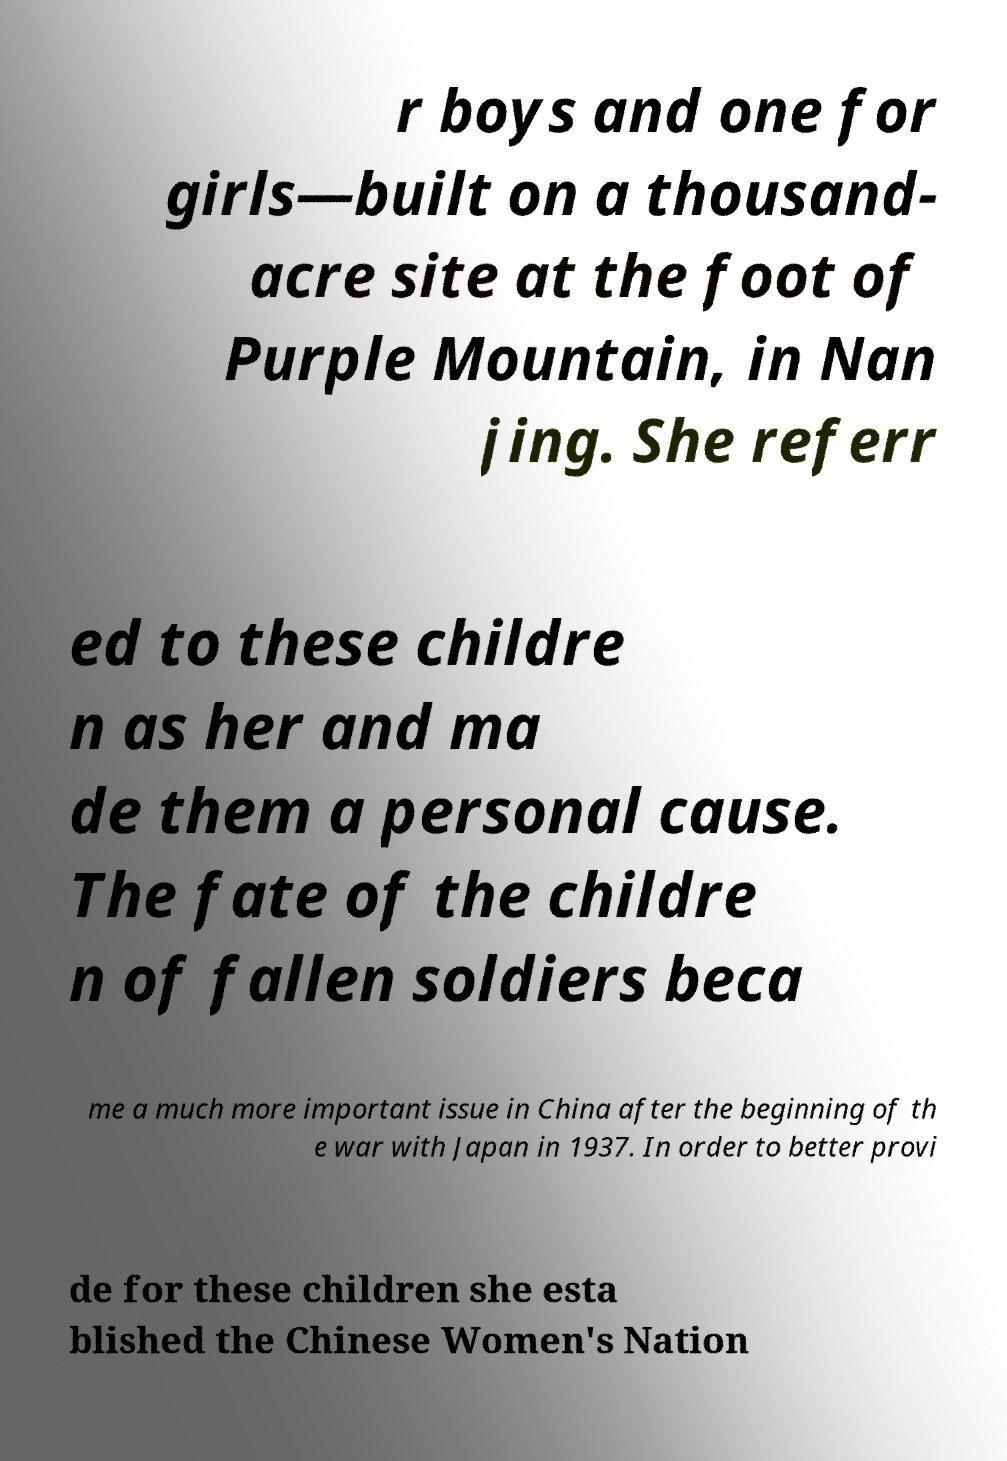Can you read and provide the text displayed in the image?This photo seems to have some interesting text. Can you extract and type it out for me? r boys and one for girls—built on a thousand- acre site at the foot of Purple Mountain, in Nan jing. She referr ed to these childre n as her and ma de them a personal cause. The fate of the childre n of fallen soldiers beca me a much more important issue in China after the beginning of th e war with Japan in 1937. In order to better provi de for these children she esta blished the Chinese Women's Nation 